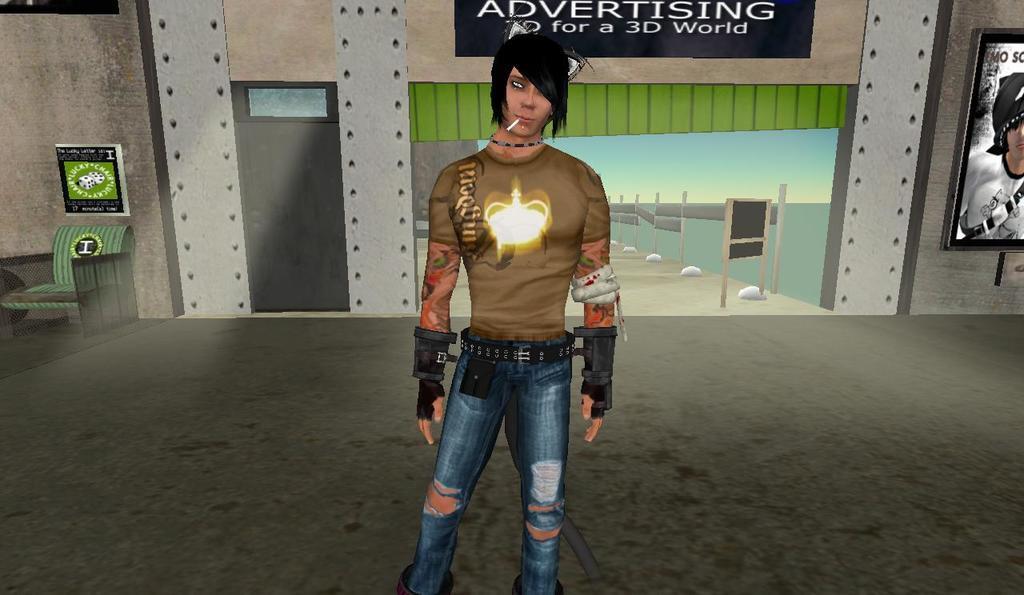How would you summarize this image in a sentence or two? In this image I can see an animated image of a man. Here I can see a door, a wall which has photo and other objects attached to it. Here I can see a chair. 